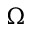Convert formula to latex. <formula><loc_0><loc_0><loc_500><loc_500>\Omega</formula> 